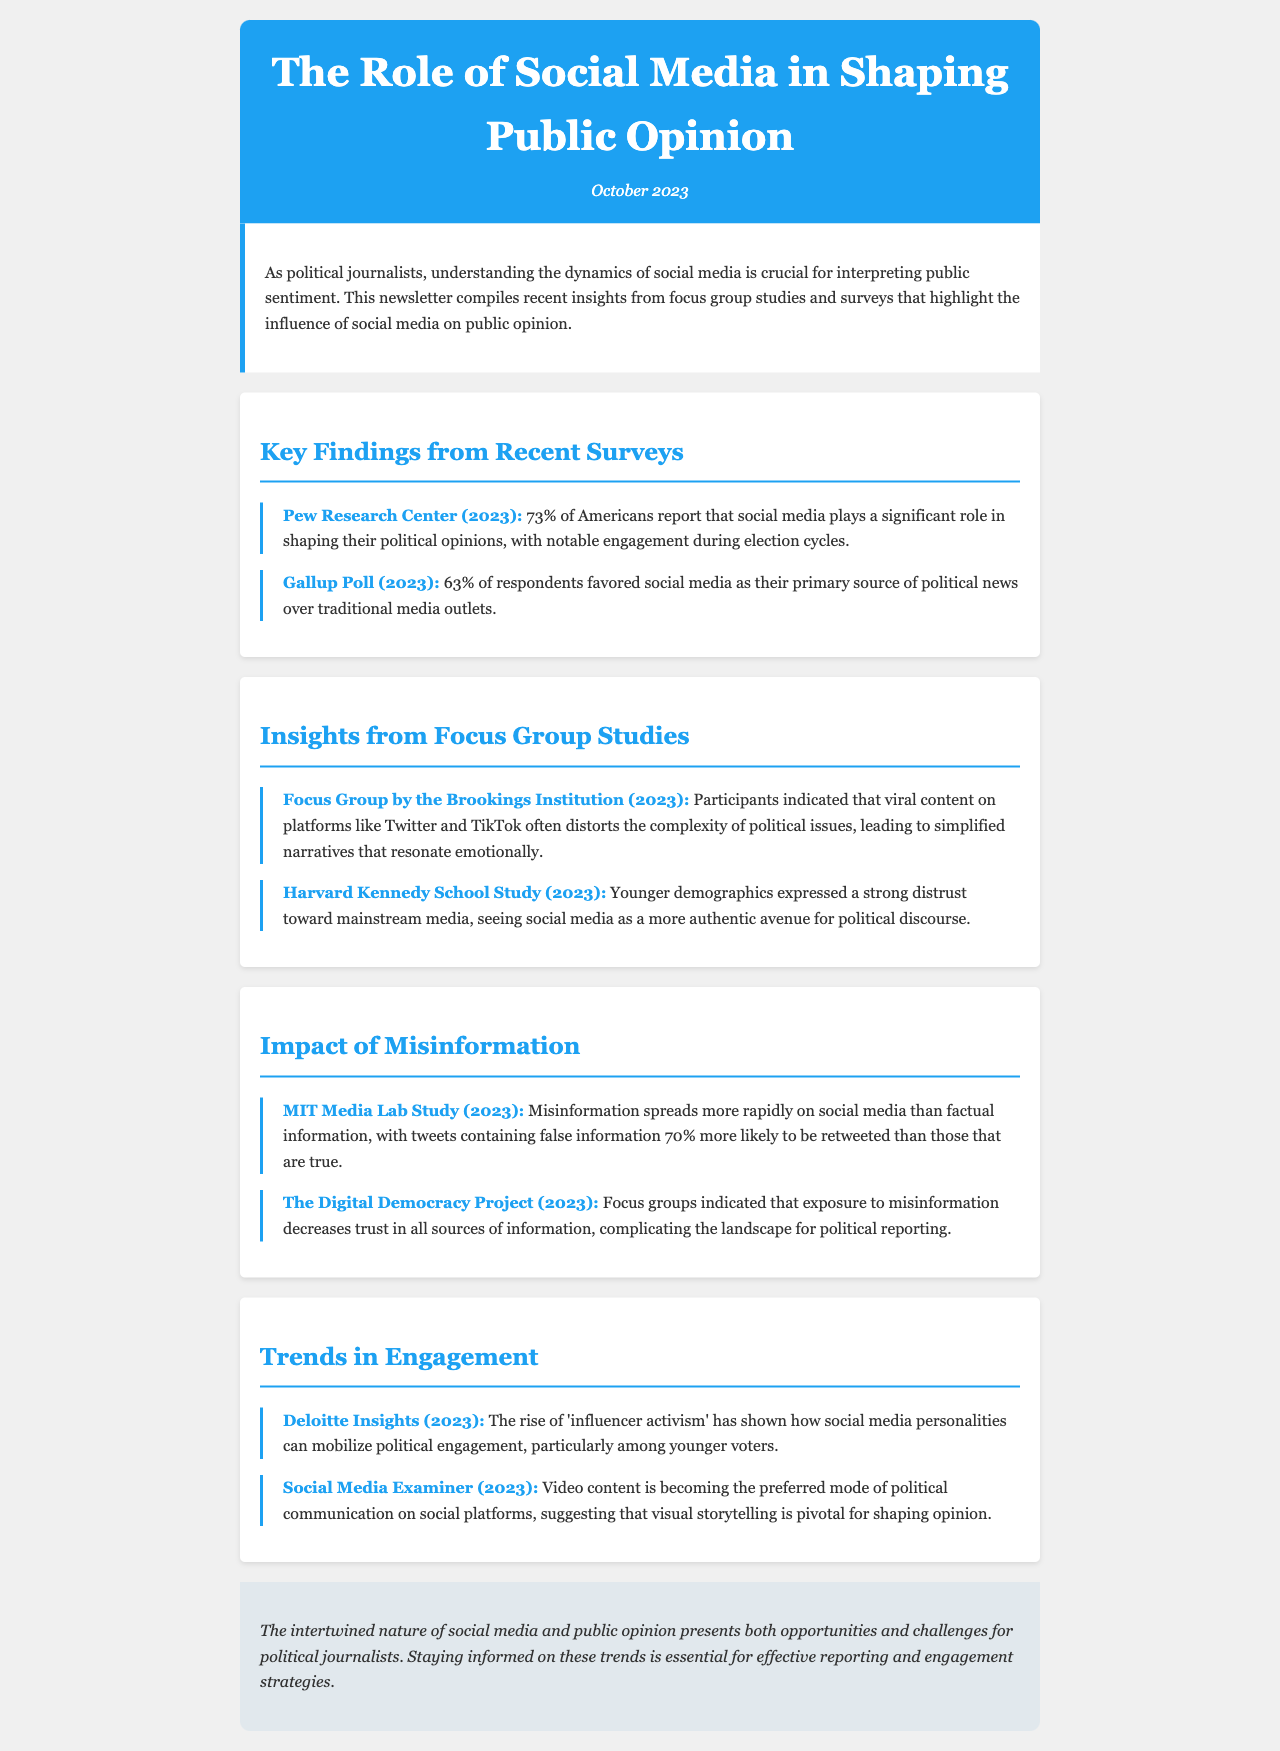What percentage of Americans say social media shapes their political opinions significantly? The document states that 73% of Americans report that social media plays a significant role in shaping their political opinions.
Answer: 73% What is the primary source of political news for 63% of respondents? According to the Gallup Poll, 63% of respondents favored social media as their primary source of political news.
Answer: Social media What major concern do focus group participants express regarding viral content on social media? Participants indicated that viral content often distorts the complexity of political issues, leading to simplified narratives.
Answer: Simplified narratives Which demographic expresses strong distrust toward mainstream media? The Harvard Kennedy School Study indicates that younger demographics expressed a strong distrust toward mainstream media.
Answer: Younger demographics What percentage more likely are tweets containing false information to be retweeted compared to true information? The MIT Media Lab Study found that tweets containing false information are 70% more likely to be retweeted than true tweets.
Answer: 70% What emerging trend is noted in relation to political engagement? Deloitte Insights points out that 'influencer activism' is a rising trend that can mobilize political engagement.
Answer: Influencer activism What type of content is becoming the preferred mode of political communication on social platforms? The Social Media Examiner reports that video content is becoming the preferred mode of political communication on social platforms.
Answer: Video content Which report highlights a decrease in trust due to misinformation? The Digital Democracy Project indicates that exposure to misinformation decreases trust in all sources of information.
Answer: The Digital Democracy Project What color is used for the header of the newsletter? The document describes the header background color as #1da1f2 (a shade of blue).
Answer: Blue 